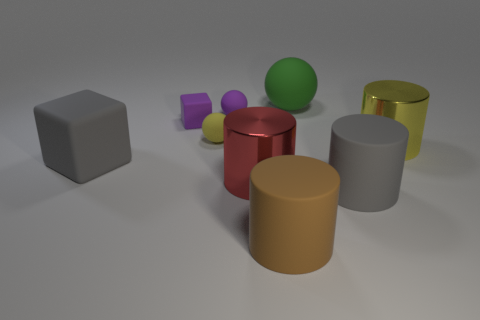Add 1 gray cylinders. How many objects exist? 10 Subtract all cylinders. How many objects are left? 5 Add 8 big cyan objects. How many big cyan objects exist? 8 Subtract 0 yellow blocks. How many objects are left? 9 Subtract all small yellow cubes. Subtract all blocks. How many objects are left? 7 Add 7 yellow shiny cylinders. How many yellow shiny cylinders are left? 8 